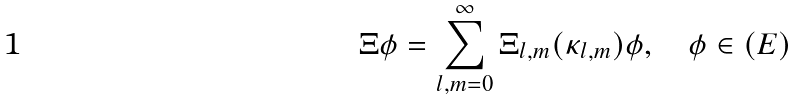<formula> <loc_0><loc_0><loc_500><loc_500>\Xi \phi = \sum _ { l , m = 0 } ^ { \infty } \Xi _ { l , m } ( \kappa _ { l , m } ) \phi , \quad \phi \in ( E )</formula> 